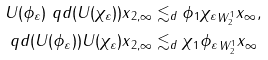Convert formula to latex. <formula><loc_0><loc_0><loc_500><loc_500>& \| U ( \phi _ { \varepsilon } ) \ q d ( U ( \chi _ { \varepsilon } ) ) x \| _ { 2 , \infty } \lesssim _ { d } \| \phi \| _ { 1 } \| \chi _ { \varepsilon } \| _ { W ^ { 1 } _ { 2 } } \| x \| _ { \infty } , \\ & \| \ q d ( U ( \phi _ { \varepsilon } ) ) U ( \chi _ { \varepsilon } ) x \| _ { 2 , \infty } \lesssim _ { d } \| \chi \| _ { 1 } \| \phi _ { \varepsilon } \| _ { W ^ { 1 } _ { 2 } } \| x \| _ { \infty }</formula> 